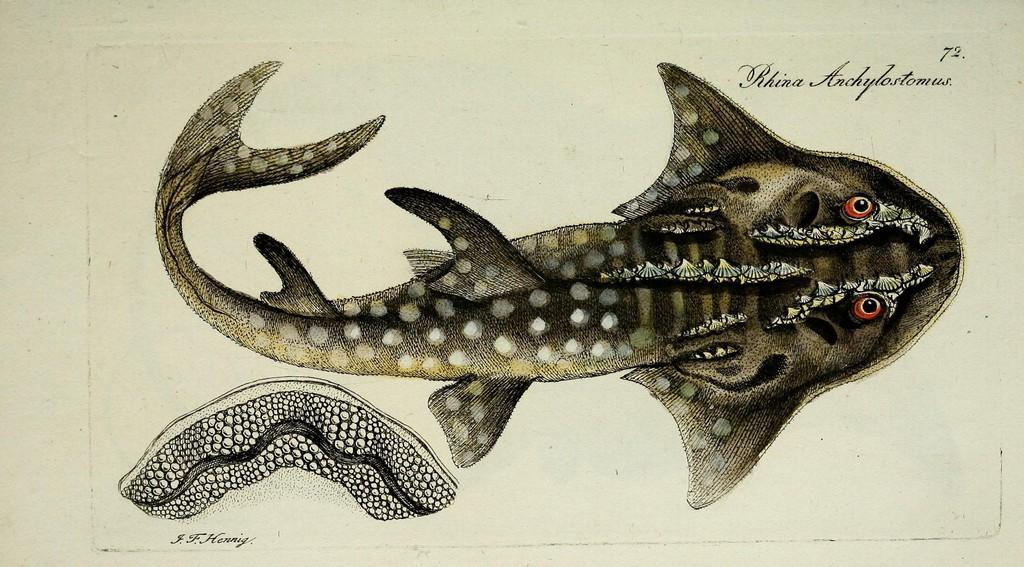What is depicted on the poster in the image? The poster features a fish. What can be observed about the fish's eyes? The fish has eyes. What other items are present on the fish in the image? There are seashells on the fish. How does the fish surprise its prey in the image? There is no indication in the image that the fish is interacting with prey or engaging in any surprise tactics. 